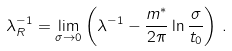Convert formula to latex. <formula><loc_0><loc_0><loc_500><loc_500>\lambda _ { R } ^ { - 1 } = \lim _ { \sigma \rightarrow 0 } \left ( \lambda ^ { - 1 } - \frac { m ^ { * } } { 2 \pi } \ln \frac { \sigma } { t _ { 0 } } \right ) \, .</formula> 